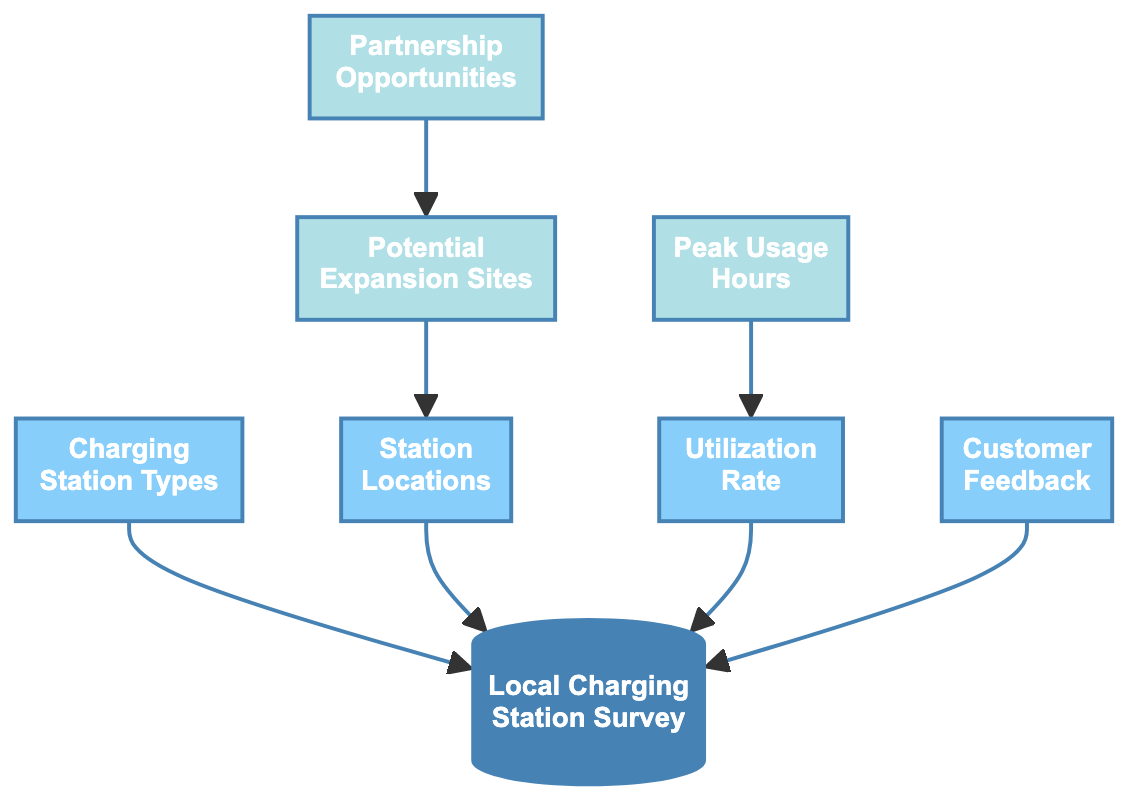What is the primary node in the diagram? The primary node is the "Local Charging Station Survey," which is at the top of the flow chart and serves as the starting point for other evaluations related to charging station availability and utilization.
Answer: Local Charging Station Survey How many types of charging stations are identified? There are three types of charging stations identified in the diagram: Level 1, Level 2, and DC Fast Charging. These types are represented as a single node labeled "Charging Station Types."
Answer: 3 Which node is connected to "Utilization Rate"? The node "Utilization Rate" is connected to "Local Charging Station Survey," indicating that utilization analysis is part of the overall survey process for assessing charging stations.
Answer: Local Charging Station Survey How many nodes are directly linked to the "Station Locations"? There is one node directly linked to "Station Locations," which is "Potential Expansion Sites." This linkage suggests that mapping charging stations leads to identifying new locations for expansion.
Answer: 1 What determines the "Peak Usage Hours"? "Peak Usage Hours" is determined by the "Utilization Rate," which analyzes how often each station is used, leading to insight into when demand is highest.
Answer: Utilization Rate Which node is the last step in evaluating opportunities for charging station installation? The last step is "Partnership Opportunities," which is based on the identification of "Potential Expansion Sites." This shows the connection from identifying sites to exploring partnerships for installing new stations.
Answer: Partnership Opportunities What is the relationship between "Customer Feedback" and "Local Charging Station Survey"? "Customer Feedback" is one of the nodes that directly connects to the "Local Charging Station Survey," indicating that feedback collection is a component of assessing existing charging stations and their accessibility.
Answer: Direct connection How many total nodes are present in the diagram? There are eight distinct nodes within the diagram that represent different aspects of evaluating local charging station availability and utilization.
Answer: 8 